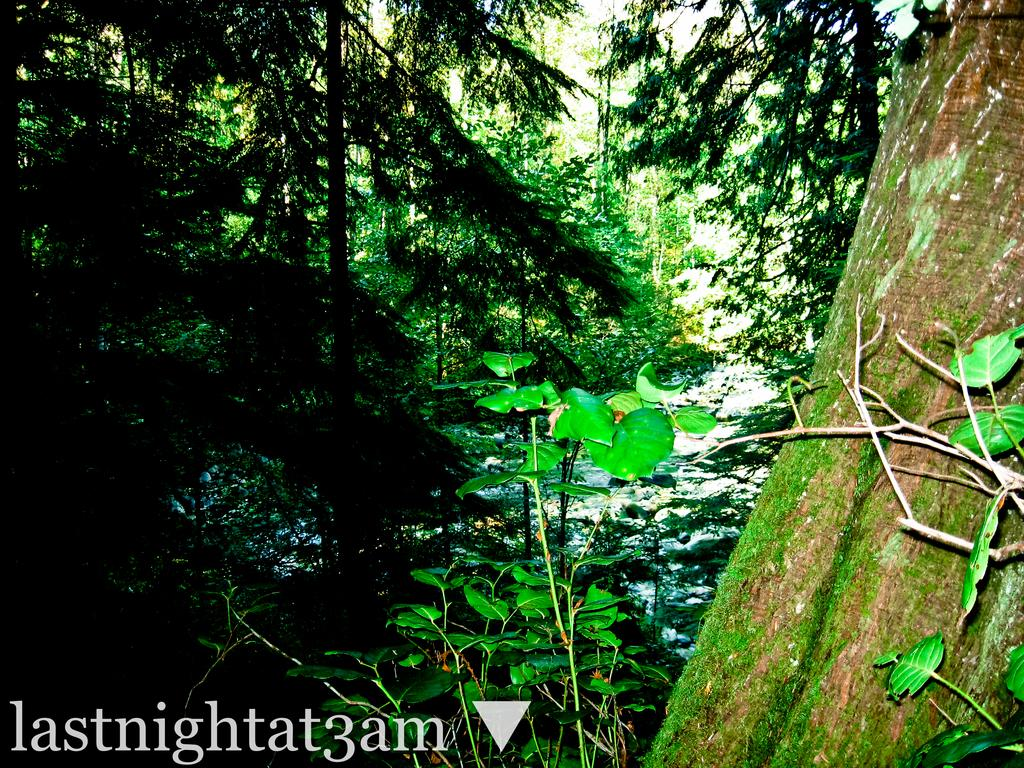What type of natural elements can be seen in the image? There are trees in the image. Where is the text located in the image? The text is on the bottom left of the image. What type of vessel is being used for pleasure in the garden depicted in the image? There is no vessel, pleasure, or garden present in the image; it only features trees and text. 